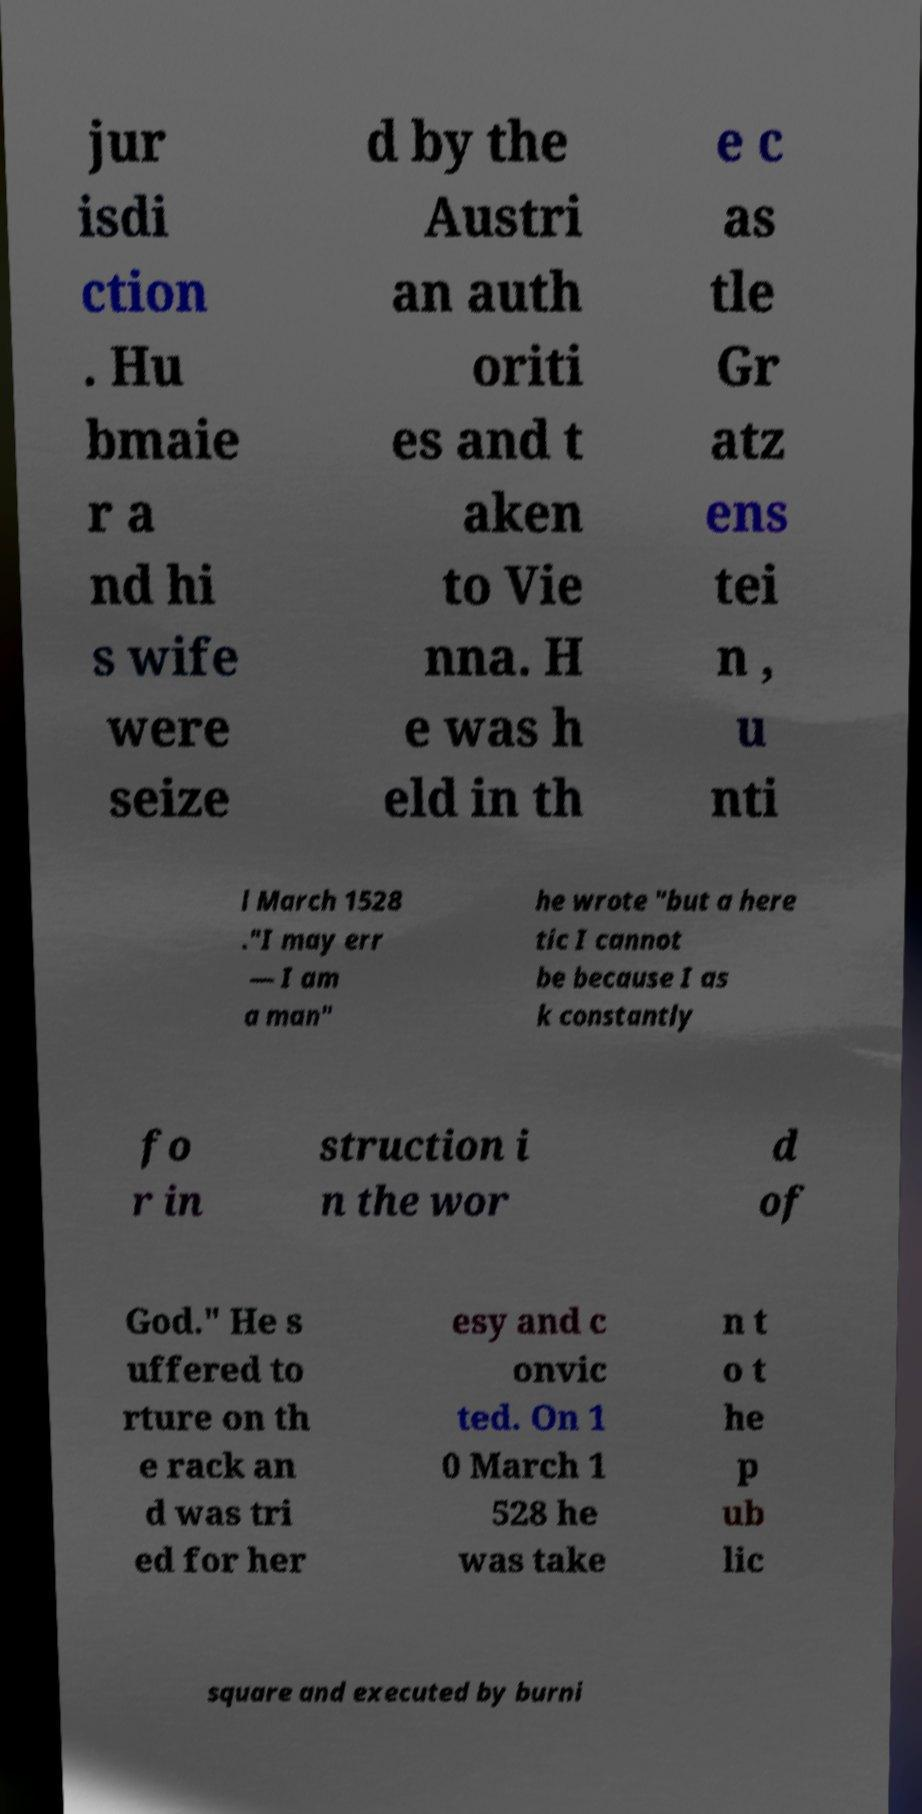Please identify and transcribe the text found in this image. jur isdi ction . Hu bmaie r a nd hi s wife were seize d by the Austri an auth oriti es and t aken to Vie nna. H e was h eld in th e c as tle Gr atz ens tei n , u nti l March 1528 ."I may err — I am a man" he wrote "but a here tic I cannot be because I as k constantly fo r in struction i n the wor d of God." He s uffered to rture on th e rack an d was tri ed for her esy and c onvic ted. On 1 0 March 1 528 he was take n t o t he p ub lic square and executed by burni 